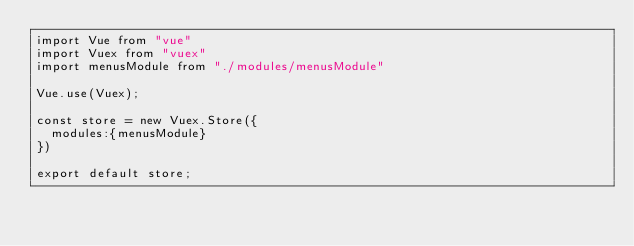<code> <loc_0><loc_0><loc_500><loc_500><_JavaScript_>import Vue from "vue"
import Vuex from "vuex"
import menusModule from "./modules/menusModule"

Vue.use(Vuex);

const store = new Vuex.Store({
  modules:{menusModule}
})

export default store;</code> 